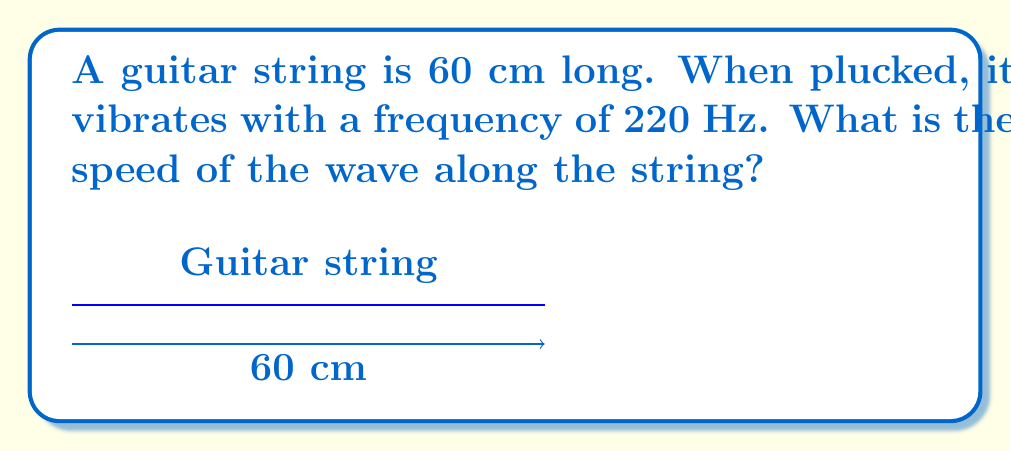Give your solution to this math problem. Let's solve this step-by-step:

1. We know the wave equation for a vibrating string:
   $$v = f\lambda$$
   where $v$ is the wave speed, $f$ is the frequency, and $\lambda$ is the wavelength.

2. We're given the frequency: $f = 220$ Hz

3. For a guitar string, the fundamental mode of vibration has nodes at both ends. This means the length of the string is half a wavelength:
   $$L = \frac{1}{2}\lambda$$

4. We know the length of the string: $L = 60$ cm $= 0.6$ m

5. Let's find the wavelength:
   $$\lambda = 2L = 2 \times 0.6 = 1.2 \text{ m}$$

6. Now we can use the wave equation:
   $$v = f\lambda = 220 \times 1.2 = 264 \text{ m/s}$$

So, the speed of the wave along the string is 264 m/s.
Answer: 264 m/s 